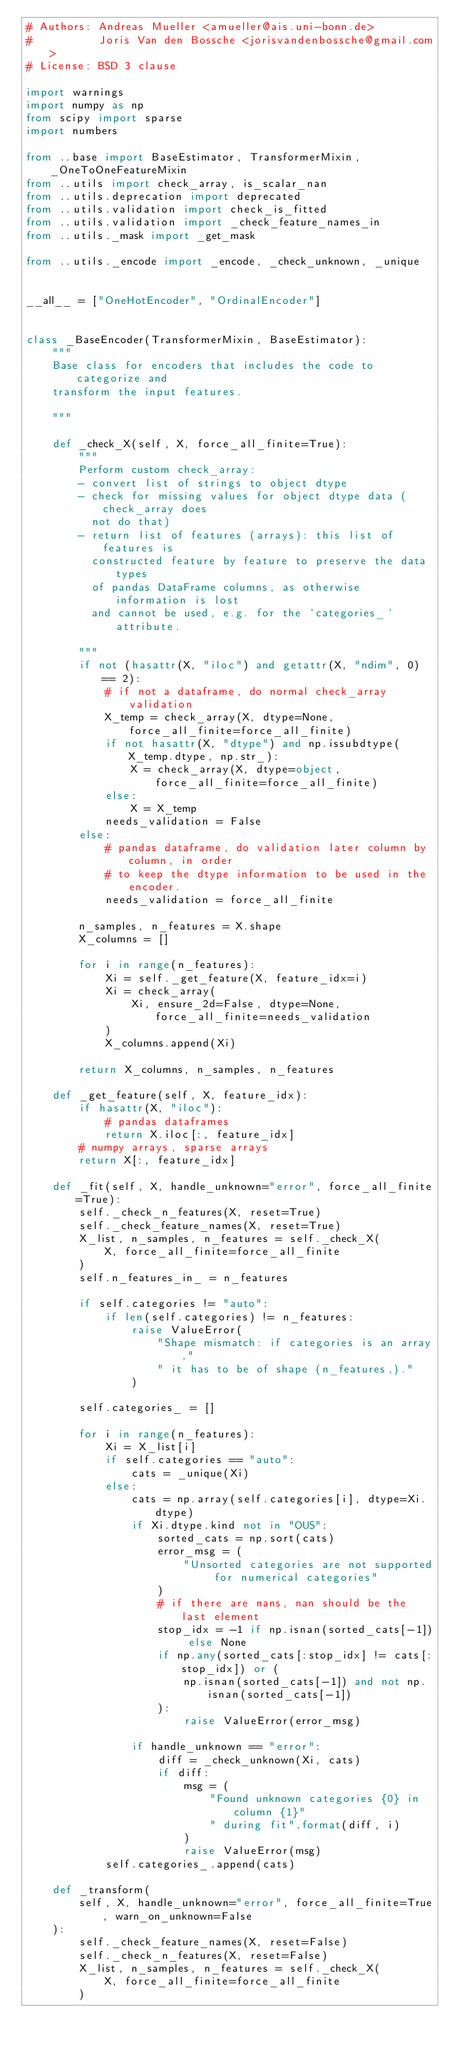Convert code to text. <code><loc_0><loc_0><loc_500><loc_500><_Python_># Authors: Andreas Mueller <amueller@ais.uni-bonn.de>
#          Joris Van den Bossche <jorisvandenbossche@gmail.com>
# License: BSD 3 clause

import warnings
import numpy as np
from scipy import sparse
import numbers

from ..base import BaseEstimator, TransformerMixin, _OneToOneFeatureMixin
from ..utils import check_array, is_scalar_nan
from ..utils.deprecation import deprecated
from ..utils.validation import check_is_fitted
from ..utils.validation import _check_feature_names_in
from ..utils._mask import _get_mask

from ..utils._encode import _encode, _check_unknown, _unique


__all__ = ["OneHotEncoder", "OrdinalEncoder"]


class _BaseEncoder(TransformerMixin, BaseEstimator):
    """
    Base class for encoders that includes the code to categorize and
    transform the input features.

    """

    def _check_X(self, X, force_all_finite=True):
        """
        Perform custom check_array:
        - convert list of strings to object dtype
        - check for missing values for object dtype data (check_array does
          not do that)
        - return list of features (arrays): this list of features is
          constructed feature by feature to preserve the data types
          of pandas DataFrame columns, as otherwise information is lost
          and cannot be used, e.g. for the `categories_` attribute.

        """
        if not (hasattr(X, "iloc") and getattr(X, "ndim", 0) == 2):
            # if not a dataframe, do normal check_array validation
            X_temp = check_array(X, dtype=None, force_all_finite=force_all_finite)
            if not hasattr(X, "dtype") and np.issubdtype(X_temp.dtype, np.str_):
                X = check_array(X, dtype=object, force_all_finite=force_all_finite)
            else:
                X = X_temp
            needs_validation = False
        else:
            # pandas dataframe, do validation later column by column, in order
            # to keep the dtype information to be used in the encoder.
            needs_validation = force_all_finite

        n_samples, n_features = X.shape
        X_columns = []

        for i in range(n_features):
            Xi = self._get_feature(X, feature_idx=i)
            Xi = check_array(
                Xi, ensure_2d=False, dtype=None, force_all_finite=needs_validation
            )
            X_columns.append(Xi)

        return X_columns, n_samples, n_features

    def _get_feature(self, X, feature_idx):
        if hasattr(X, "iloc"):
            # pandas dataframes
            return X.iloc[:, feature_idx]
        # numpy arrays, sparse arrays
        return X[:, feature_idx]

    def _fit(self, X, handle_unknown="error", force_all_finite=True):
        self._check_n_features(X, reset=True)
        self._check_feature_names(X, reset=True)
        X_list, n_samples, n_features = self._check_X(
            X, force_all_finite=force_all_finite
        )
        self.n_features_in_ = n_features

        if self.categories != "auto":
            if len(self.categories) != n_features:
                raise ValueError(
                    "Shape mismatch: if categories is an array,"
                    " it has to be of shape (n_features,)."
                )

        self.categories_ = []

        for i in range(n_features):
            Xi = X_list[i]
            if self.categories == "auto":
                cats = _unique(Xi)
            else:
                cats = np.array(self.categories[i], dtype=Xi.dtype)
                if Xi.dtype.kind not in "OUS":
                    sorted_cats = np.sort(cats)
                    error_msg = (
                        "Unsorted categories are not supported for numerical categories"
                    )
                    # if there are nans, nan should be the last element
                    stop_idx = -1 if np.isnan(sorted_cats[-1]) else None
                    if np.any(sorted_cats[:stop_idx] != cats[:stop_idx]) or (
                        np.isnan(sorted_cats[-1]) and not np.isnan(sorted_cats[-1])
                    ):
                        raise ValueError(error_msg)

                if handle_unknown == "error":
                    diff = _check_unknown(Xi, cats)
                    if diff:
                        msg = (
                            "Found unknown categories {0} in column {1}"
                            " during fit".format(diff, i)
                        )
                        raise ValueError(msg)
            self.categories_.append(cats)

    def _transform(
        self, X, handle_unknown="error", force_all_finite=True, warn_on_unknown=False
    ):
        self._check_feature_names(X, reset=False)
        self._check_n_features(X, reset=False)
        X_list, n_samples, n_features = self._check_X(
            X, force_all_finite=force_all_finite
        )
</code> 